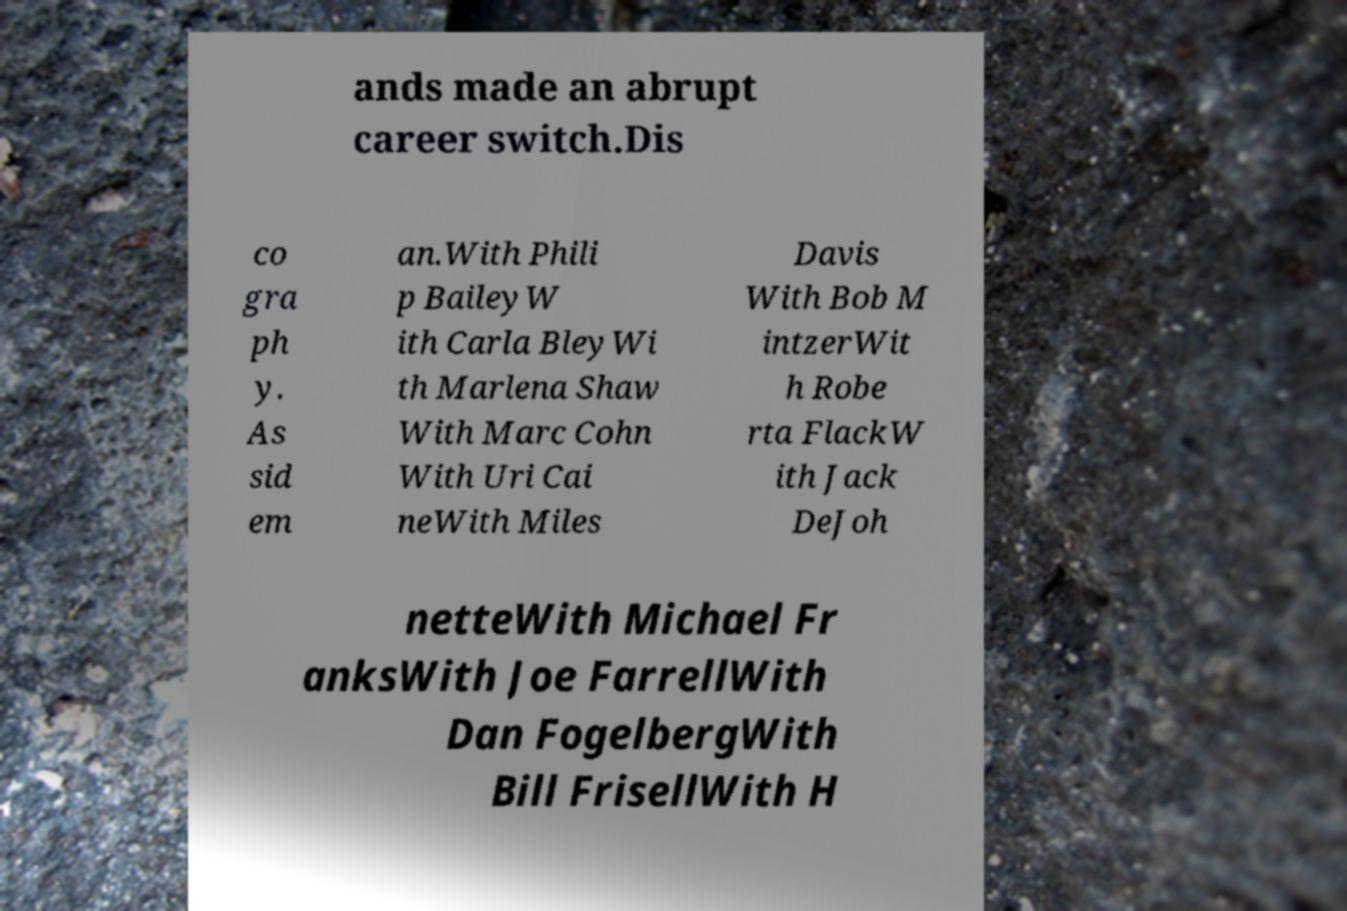I need the written content from this picture converted into text. Can you do that? ands made an abrupt career switch.Dis co gra ph y. As sid em an.With Phili p BaileyW ith Carla BleyWi th Marlena Shaw With Marc Cohn With Uri Cai neWith Miles Davis With Bob M intzerWit h Robe rta FlackW ith Jack DeJoh netteWith Michael Fr anksWith Joe FarrellWith Dan FogelbergWith Bill FrisellWith H 